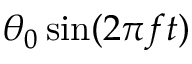<formula> <loc_0><loc_0><loc_500><loc_500>\theta _ { 0 } \sin ( 2 \pi f t )</formula> 